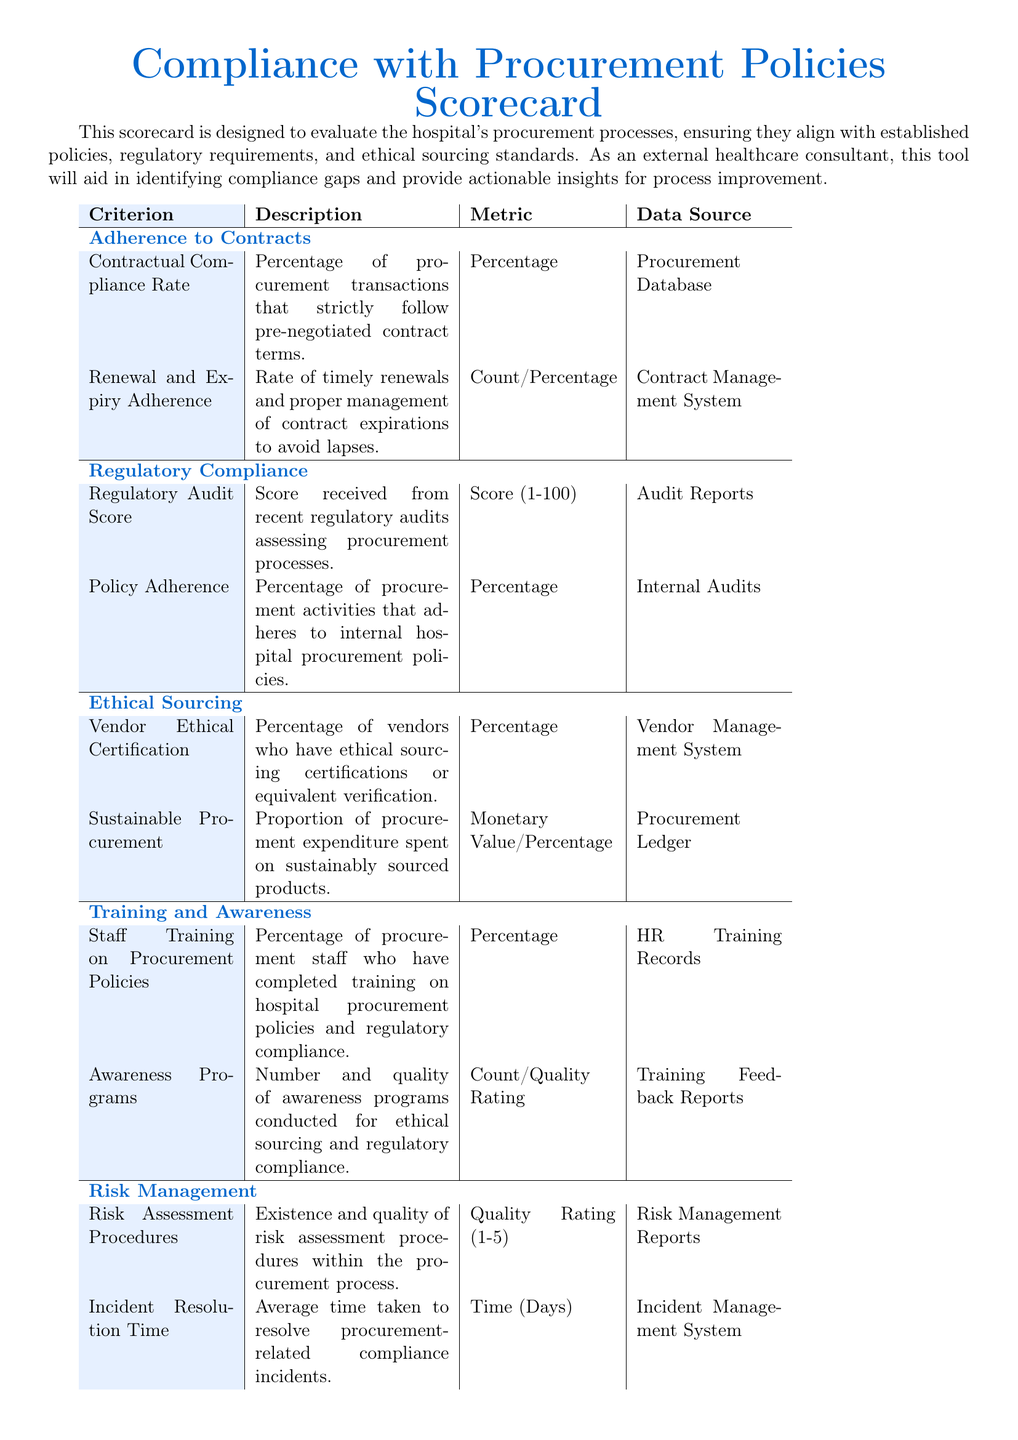what is the percentage of procurement transactions that follow contract terms? The percentage of procurement transactions that strictly follow pre-negotiated contract terms is labeled as Contractual Compliance Rate.
Answer: Percentage what is the score received from recent regulatory audits? The score received from recent regulatory audits assessing procurement processes is labeled as Regulatory Audit Score.
Answer: Score (1-100) what percentage of vendors have ethical sourcing certifications? The percentage of vendors who have ethical sourcing certifications or equivalent verification is labeled as Vendor Ethical Certification.
Answer: Percentage what is the count of awareness programs conducted for ethical sourcing? The number of awareness programs conducted for ethical sourcing and regulatory compliance is labeled as Awareness Programs.
Answer: Count/Quality Rating what is the quality rating for risk assessment procedures? The existence and quality of risk assessment procedures within the procurement process is rated on a scale of 1 to 5 and is labeled as Risk Assessment Procedures.
Answer: Quality Rating (1-5) how many employees have completed training on procurement policies? The percentage of procurement staff who have completed training on hospital procurement policies and regulatory compliance is labeled as Staff Training on Procurement Policies.
Answer: Percentage what is the average time taken to resolve procurement-related compliance incidents? The average time taken to resolve procurement-related compliance incidents is labeled as Incident Resolution Time.
Answer: Time (Days) what is the proportion of procurement expenditure spent on sustainably sourced products? The proportion of procurement expenditure spent on sustainably sourced products is labeled as Sustainable Procurement.
Answer: Monetary Value/Percentage 